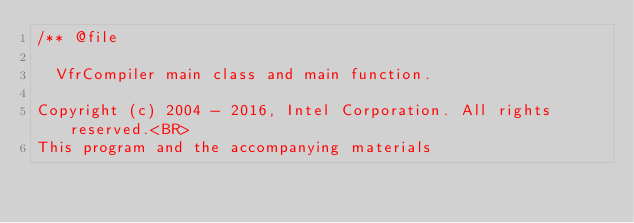Convert code to text. <code><loc_0><loc_0><loc_500><loc_500><_C++_>/** @file
  
  VfrCompiler main class and main function.

Copyright (c) 2004 - 2016, Intel Corporation. All rights reserved.<BR>
This program and the accompanying materials                          </code> 